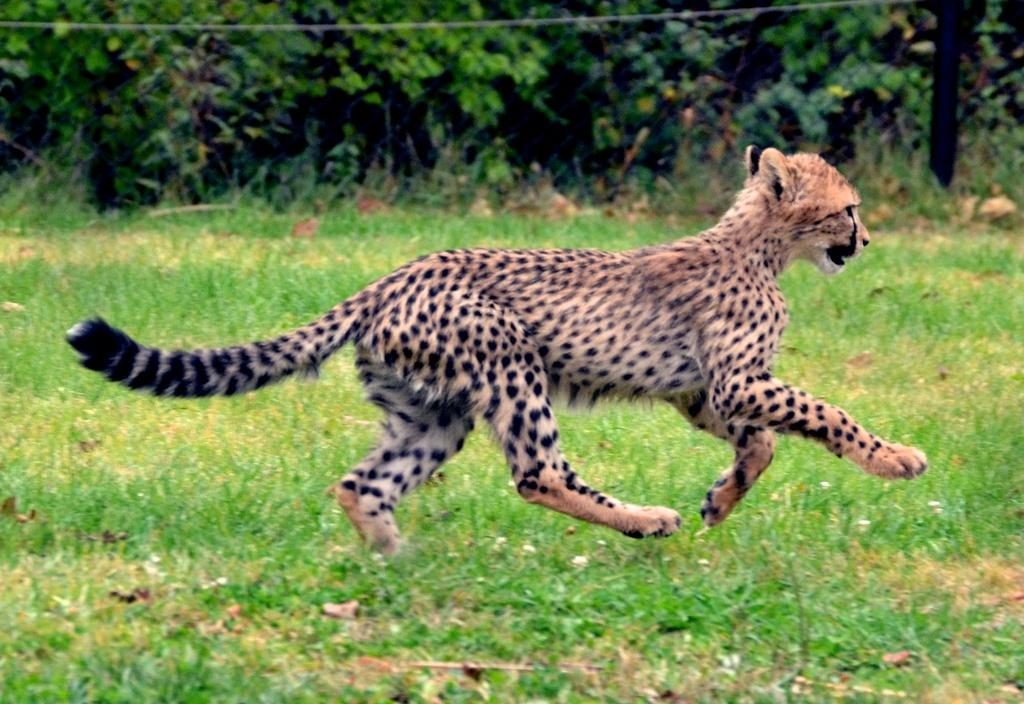What animal is the main subject of the image? There is a cheetah in the image. What is the cheetah doing in the image? The cheetah is running on the grass. What can be seen in the background of the image? There are trees in the background of the image. What type of order is the cheetah following in the image? There is no indication in the image that the cheetah is following any specific order. 